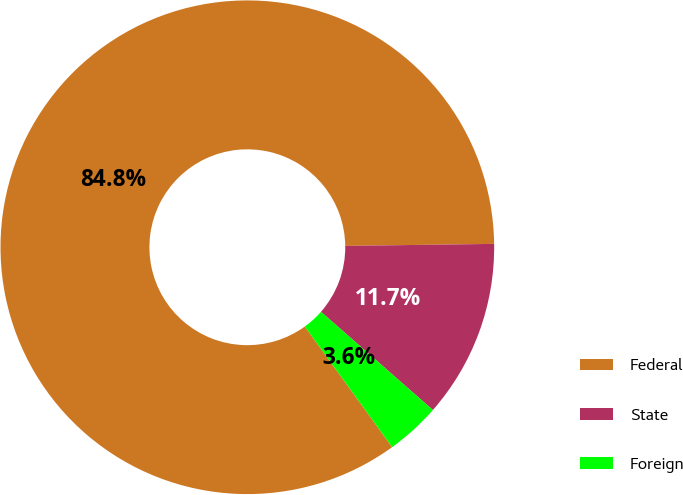Convert chart. <chart><loc_0><loc_0><loc_500><loc_500><pie_chart><fcel>Federal<fcel>State<fcel>Foreign<nl><fcel>84.77%<fcel>11.68%<fcel>3.56%<nl></chart> 